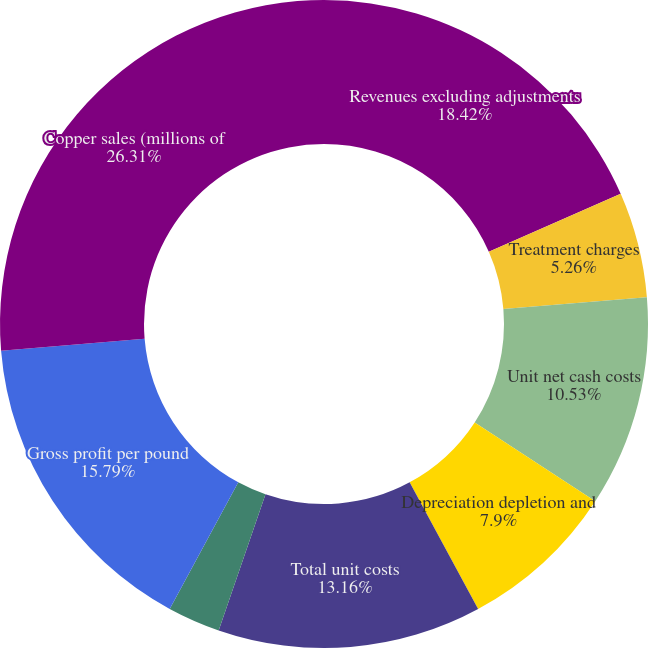Convert chart to OTSL. <chart><loc_0><loc_0><loc_500><loc_500><pie_chart><fcel>Revenues excluding adjustments<fcel>Treatment charges<fcel>Unit net cash costs<fcel>Depreciation depletion and<fcel>Noncash and other costs net<fcel>Total unit costs<fcel>prior period open sales<fcel>Gross profit per pound<fcel>Copper sales (millions of<nl><fcel>18.42%<fcel>5.26%<fcel>10.53%<fcel>7.9%<fcel>0.0%<fcel>13.16%<fcel>2.63%<fcel>15.79%<fcel>26.31%<nl></chart> 